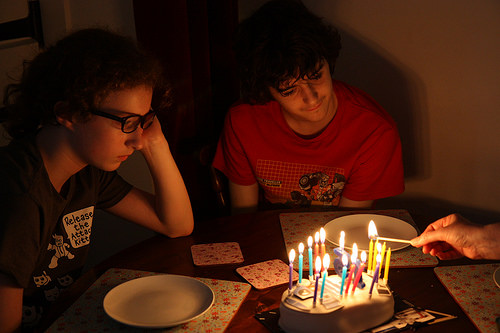<image>
Is the birthday cake to the left of the girl? No. The birthday cake is not to the left of the girl. From this viewpoint, they have a different horizontal relationship. Where is the plate in relation to the cake? Is it under the cake? No. The plate is not positioned under the cake. The vertical relationship between these objects is different. 